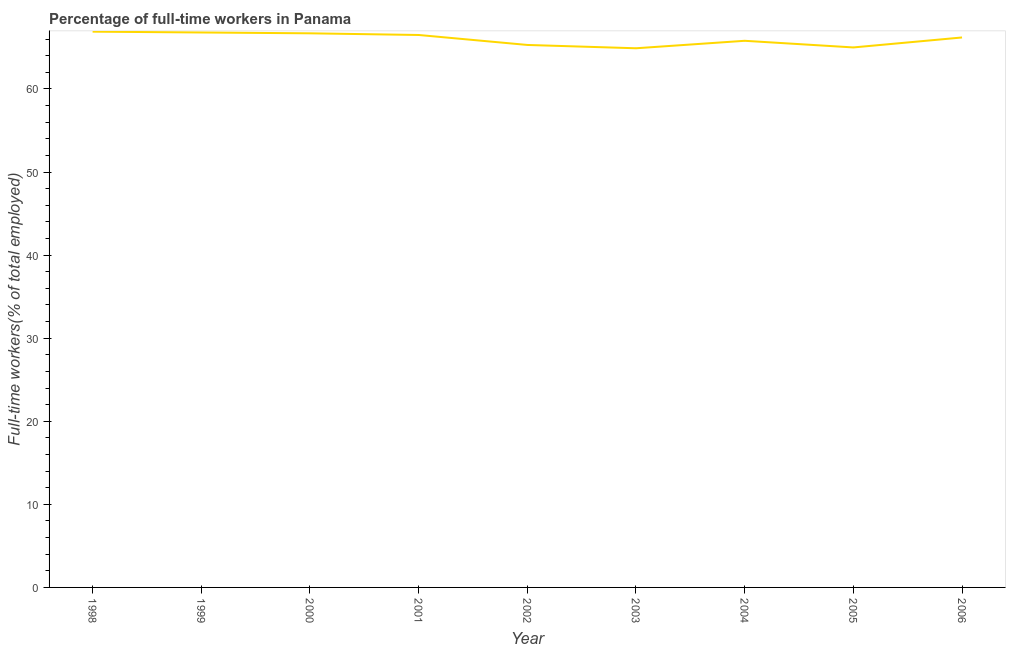What is the percentage of full-time workers in 2000?
Provide a short and direct response. 66.7. Across all years, what is the maximum percentage of full-time workers?
Give a very brief answer. 66.9. Across all years, what is the minimum percentage of full-time workers?
Keep it short and to the point. 64.9. In which year was the percentage of full-time workers maximum?
Your answer should be very brief. 1998. In which year was the percentage of full-time workers minimum?
Offer a terse response. 2003. What is the sum of the percentage of full-time workers?
Provide a succinct answer. 594.1. What is the average percentage of full-time workers per year?
Your answer should be very brief. 66.01. What is the median percentage of full-time workers?
Your response must be concise. 66.2. In how many years, is the percentage of full-time workers greater than 18 %?
Give a very brief answer. 9. What is the ratio of the percentage of full-time workers in 2001 to that in 2006?
Give a very brief answer. 1. What is the difference between the highest and the second highest percentage of full-time workers?
Keep it short and to the point. 0.1. In how many years, is the percentage of full-time workers greater than the average percentage of full-time workers taken over all years?
Your response must be concise. 5. Does the percentage of full-time workers monotonically increase over the years?
Your answer should be compact. No. How many lines are there?
Offer a terse response. 1. Does the graph contain any zero values?
Keep it short and to the point. No. Does the graph contain grids?
Ensure brevity in your answer.  No. What is the title of the graph?
Your answer should be compact. Percentage of full-time workers in Panama. What is the label or title of the X-axis?
Give a very brief answer. Year. What is the label or title of the Y-axis?
Offer a very short reply. Full-time workers(% of total employed). What is the Full-time workers(% of total employed) in 1998?
Your answer should be compact. 66.9. What is the Full-time workers(% of total employed) in 1999?
Offer a very short reply. 66.8. What is the Full-time workers(% of total employed) of 2000?
Ensure brevity in your answer.  66.7. What is the Full-time workers(% of total employed) in 2001?
Keep it short and to the point. 66.5. What is the Full-time workers(% of total employed) in 2002?
Your response must be concise. 65.3. What is the Full-time workers(% of total employed) in 2003?
Provide a short and direct response. 64.9. What is the Full-time workers(% of total employed) of 2004?
Your answer should be very brief. 65.8. What is the Full-time workers(% of total employed) in 2006?
Provide a short and direct response. 66.2. What is the difference between the Full-time workers(% of total employed) in 1998 and 2000?
Keep it short and to the point. 0.2. What is the difference between the Full-time workers(% of total employed) in 1998 and 2004?
Your answer should be very brief. 1.1. What is the difference between the Full-time workers(% of total employed) in 1998 and 2005?
Ensure brevity in your answer.  1.9. What is the difference between the Full-time workers(% of total employed) in 1999 and 2000?
Provide a short and direct response. 0.1. What is the difference between the Full-time workers(% of total employed) in 1999 and 2002?
Ensure brevity in your answer.  1.5. What is the difference between the Full-time workers(% of total employed) in 1999 and 2004?
Make the answer very short. 1. What is the difference between the Full-time workers(% of total employed) in 1999 and 2006?
Your response must be concise. 0.6. What is the difference between the Full-time workers(% of total employed) in 2000 and 2001?
Offer a very short reply. 0.2. What is the difference between the Full-time workers(% of total employed) in 2000 and 2002?
Your response must be concise. 1.4. What is the difference between the Full-time workers(% of total employed) in 2000 and 2003?
Make the answer very short. 1.8. What is the difference between the Full-time workers(% of total employed) in 2000 and 2004?
Your answer should be compact. 0.9. What is the difference between the Full-time workers(% of total employed) in 2000 and 2005?
Ensure brevity in your answer.  1.7. What is the difference between the Full-time workers(% of total employed) in 2001 and 2002?
Give a very brief answer. 1.2. What is the difference between the Full-time workers(% of total employed) in 2001 and 2003?
Provide a short and direct response. 1.6. What is the difference between the Full-time workers(% of total employed) in 2002 and 2006?
Keep it short and to the point. -0.9. What is the difference between the Full-time workers(% of total employed) in 2003 and 2005?
Keep it short and to the point. -0.1. What is the difference between the Full-time workers(% of total employed) in 2003 and 2006?
Your answer should be compact. -1.3. What is the difference between the Full-time workers(% of total employed) in 2004 and 2006?
Keep it short and to the point. -0.4. What is the difference between the Full-time workers(% of total employed) in 2005 and 2006?
Provide a short and direct response. -1.2. What is the ratio of the Full-time workers(% of total employed) in 1998 to that in 2002?
Ensure brevity in your answer.  1.02. What is the ratio of the Full-time workers(% of total employed) in 1998 to that in 2003?
Provide a short and direct response. 1.03. What is the ratio of the Full-time workers(% of total employed) in 1998 to that in 2004?
Your response must be concise. 1.02. What is the ratio of the Full-time workers(% of total employed) in 1998 to that in 2005?
Give a very brief answer. 1.03. What is the ratio of the Full-time workers(% of total employed) in 1998 to that in 2006?
Your answer should be compact. 1.01. What is the ratio of the Full-time workers(% of total employed) in 1999 to that in 2001?
Provide a short and direct response. 1. What is the ratio of the Full-time workers(% of total employed) in 1999 to that in 2003?
Offer a very short reply. 1.03. What is the ratio of the Full-time workers(% of total employed) in 1999 to that in 2004?
Your response must be concise. 1.01. What is the ratio of the Full-time workers(% of total employed) in 1999 to that in 2005?
Offer a terse response. 1.03. What is the ratio of the Full-time workers(% of total employed) in 2000 to that in 2003?
Your response must be concise. 1.03. What is the ratio of the Full-time workers(% of total employed) in 2000 to that in 2004?
Offer a very short reply. 1.01. What is the ratio of the Full-time workers(% of total employed) in 2001 to that in 2004?
Your answer should be compact. 1.01. What is the ratio of the Full-time workers(% of total employed) in 2001 to that in 2005?
Make the answer very short. 1.02. What is the ratio of the Full-time workers(% of total employed) in 2001 to that in 2006?
Provide a short and direct response. 1. What is the ratio of the Full-time workers(% of total employed) in 2002 to that in 2003?
Your answer should be compact. 1.01. What is the ratio of the Full-time workers(% of total employed) in 2002 to that in 2004?
Ensure brevity in your answer.  0.99. What is the ratio of the Full-time workers(% of total employed) in 2002 to that in 2005?
Give a very brief answer. 1. What is the ratio of the Full-time workers(% of total employed) in 2002 to that in 2006?
Offer a very short reply. 0.99. What is the ratio of the Full-time workers(% of total employed) in 2003 to that in 2005?
Offer a very short reply. 1. What is the ratio of the Full-time workers(% of total employed) in 2004 to that in 2005?
Ensure brevity in your answer.  1.01. What is the ratio of the Full-time workers(% of total employed) in 2004 to that in 2006?
Your response must be concise. 0.99. What is the ratio of the Full-time workers(% of total employed) in 2005 to that in 2006?
Provide a succinct answer. 0.98. 